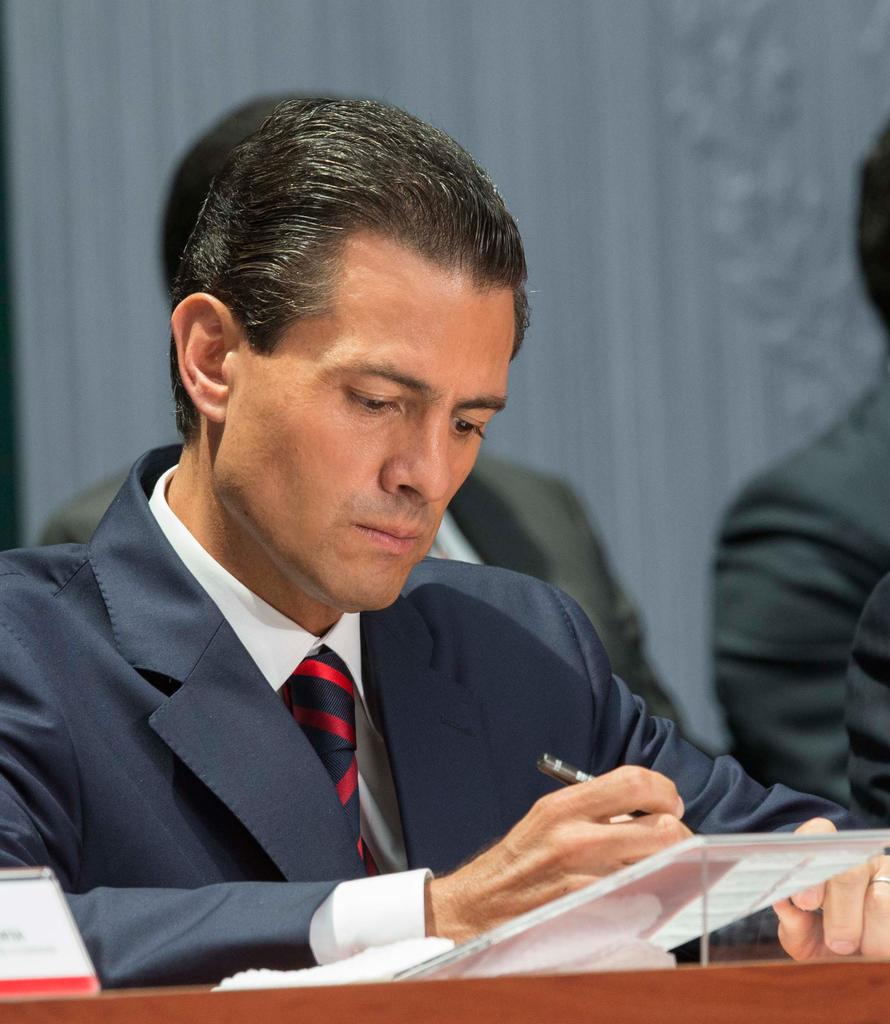How many people are in the image? There are people in the image. Can you describe the man in the front? The man in the front is holding an object in his hand and is wearing a tie, a shirt, and a coat. What can be said about the background of the image? The background of the image is blurred. What type of bird is causing a commotion in the image? There is no bird present in the image, nor is there any indication of a commotion. How many tickets are visible in the image? There is no mention of tickets in the provided facts, so it cannot be determined if any are visible in the image. 